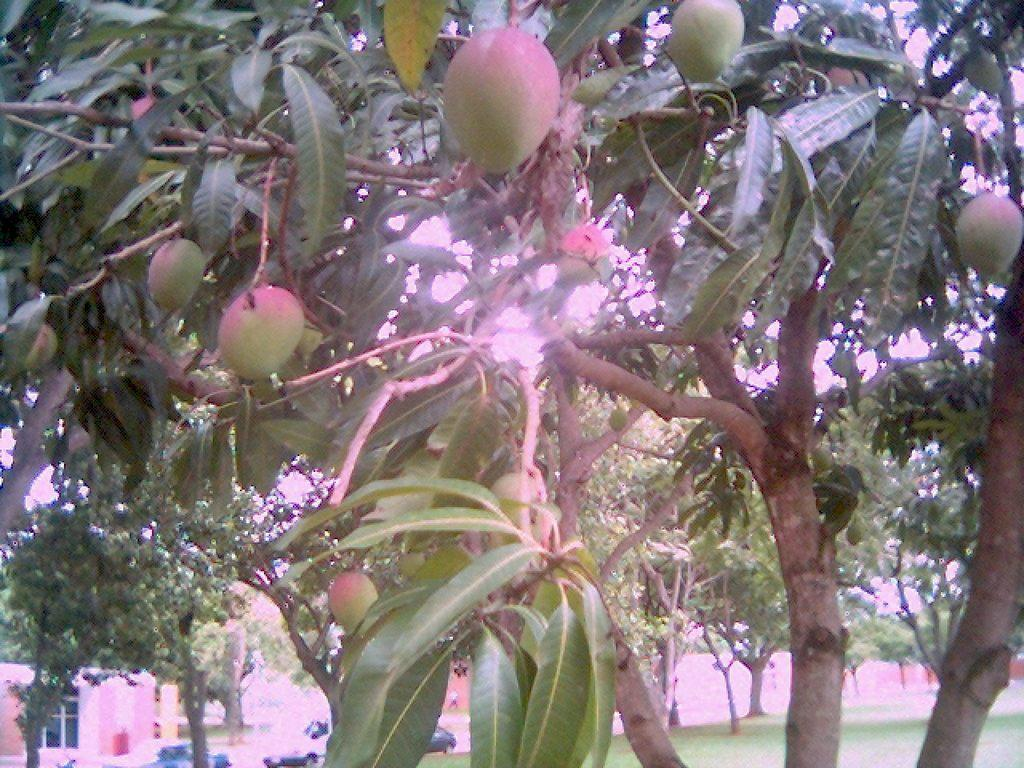What type of living organisms can be seen on the trees in the image? There are fruits on trees in the image. What structures can be seen in the background of the image? There are houses visible in the background of the image. What type of vegetation is visible in the background of the image? There are trees in the background of the image. What type of table is visible in the image? There is no table present in the image. Can you tell me how many seeds are visible in the image? There is no specific mention of seeds in the image, only fruits on trees. What type of relation can be seen between the houses and the trees in the image? There is no specific mention of a relation between the houses and the trees in the image; they are simply visible in the background. 